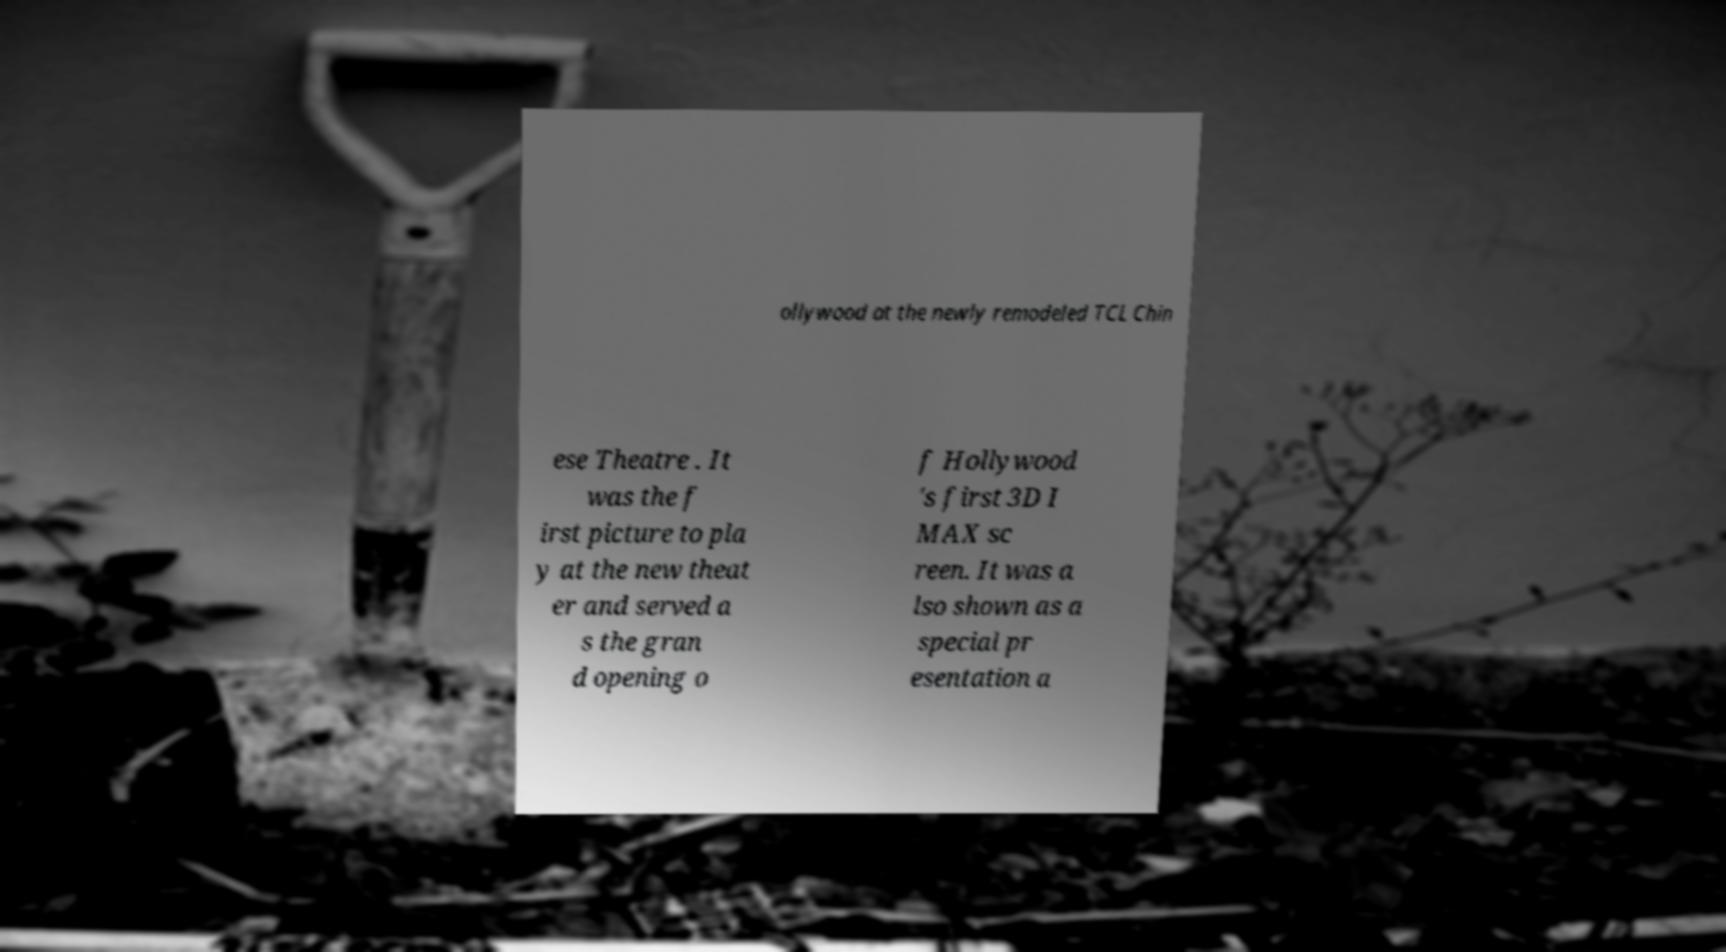Could you extract and type out the text from this image? ollywood at the newly remodeled TCL Chin ese Theatre . It was the f irst picture to pla y at the new theat er and served a s the gran d opening o f Hollywood 's first 3D I MAX sc reen. It was a lso shown as a special pr esentation a 